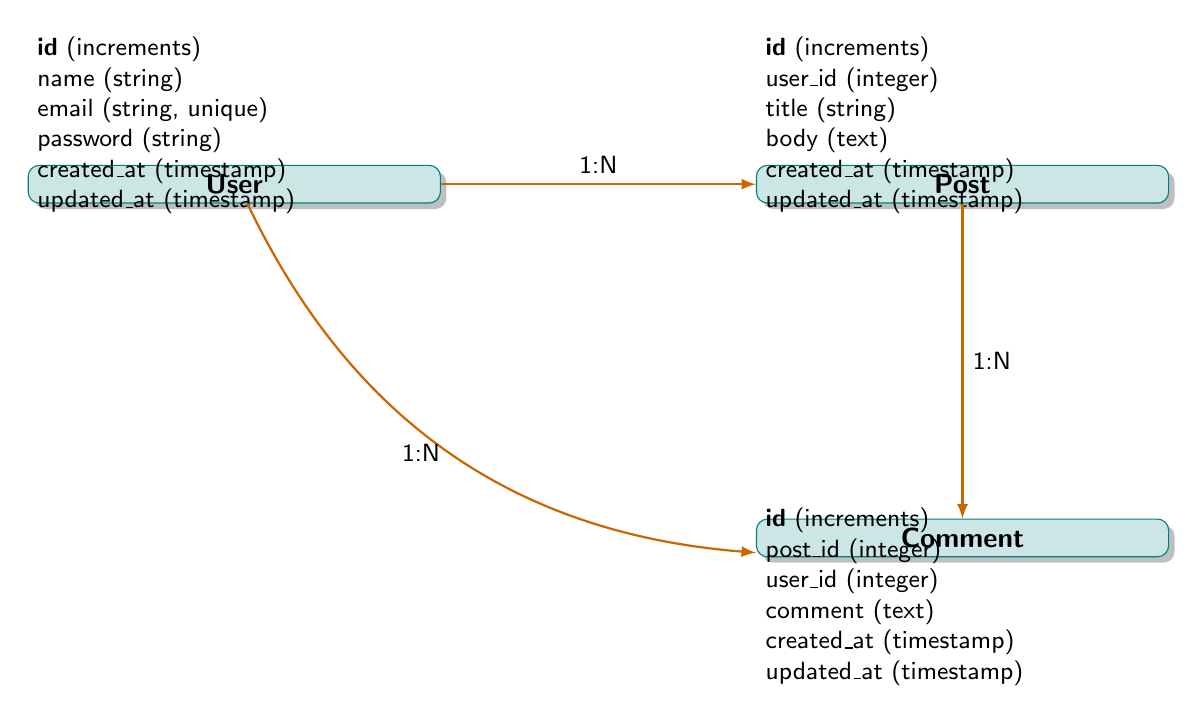What is the primary key of the User entity? The primary key of the User entity is identified by the attribute labeled as "id", which is of type "increments". In the diagram, this can be directly observed in the list of attributes associated with the User entity.
Answer: id How many attributes does the Post entity have? The Post entity has six attributes listed under its attributes section: id, user_id, title, body, created_at, and updated_at. Hence, by counting these, we determine there are six attributes.
Answer: 6 What type of relationship exists between User and Post? The relationship between User and Post is labeled as "1:N" (one-to-many) in the diagram, meaning one User can be associated with multiple Posts. This is shown on the relationship line between these two entities.
Answer: one-to-many Which entity is related to Comment through post_id? The Comment entity has a relationship with the Post entity through the foreign key post_id. This connection is indicated in the relationship section where Comment points back to Post.
Answer: Post What is the foreign key in the Comment entity that relates it to the User entity? The foreign key in the Comment entity that relates it to the User entity is labeled as user_id. This is listed among the attributes of the Comment entity and connects comments to the users who made them.
Answer: user_id How many relationships involve the Comment entity? The Comment entity is involved in two relationships: one with the Post entity and another with the User entity. This can be concluded by reviewing the relationship connections originating from Comment in the diagram.
Answer: 2 What does the "1:N" notation signify in the relationships? The "1:N" notation signifies a one-to-many relationship, indicating that an entity on the "one" side can be associated with multiple entities on the "many" side. In this diagram, it appears in the connections between User and Post, as well as User and Comment.
Answer: one-to-many Which entity does the Post entity have a foreign key reference to? The Post entity references the User entity through its foreign key user_id, indicating that each Post is associated with one User. This is shown in the attributes of the Post entity.
Answer: User 